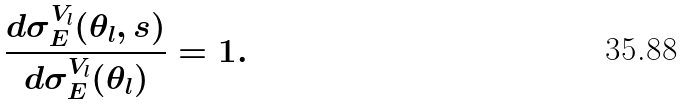Convert formula to latex. <formula><loc_0><loc_0><loc_500><loc_500>\frac { d \sigma _ { E } ^ { V _ { l } } ( \theta _ { l } , s ) } { d \sigma _ { E } ^ { V _ { l } } ( \theta _ { l } ) } = 1 .</formula> 